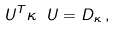<formula> <loc_0><loc_0><loc_500><loc_500>U ^ { T } \kappa \ U = D _ { \kappa } \, ,</formula> 